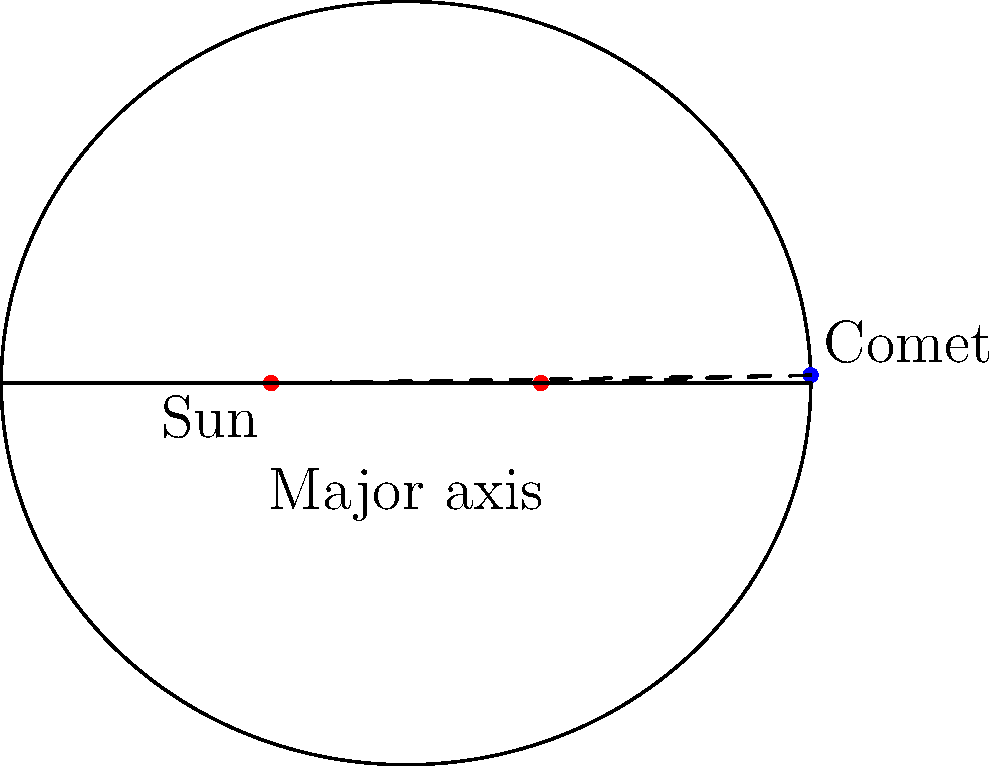In this simplified diagram of a comet's elliptical orbit around the sun, which point represents the comet's perihelion (closest approach to the sun)? How does this relate to the comet's velocity in its orbit? To answer this question, let's break it down step-by-step:

1. The elliptical orbit has two focal points. In this diagram, one focal point represents the sun.

2. The perihelion is the point in the comet's orbit where it's closest to the sun.

3. In an elliptical orbit, the object being orbited (in this case, the sun) is always located at one of the focal points.

4. The point on the ellipse closest to the occupied focal point is the perihelion.

5. In this diagram, the left focal point is labeled "Sun", so the perihelion would be the point on the ellipse closest to this focal point.

6. This point would be where the ellipse intersects the major axis on the left side of the diagram.

7. Regarding velocity, Kepler's Second Law states that a line segment joining a planet and the sun sweeps out equal areas during equal intervals of time.

8. This means that the comet moves fastest at perihelion and slowest at aphelion (the farthest point from the sun).

9. The increased velocity at perihelion is due to the conservation of angular momentum and the stronger gravitational pull when the comet is closer to the sun.
Answer: The left intersection of the ellipse with the major axis; highest velocity point 